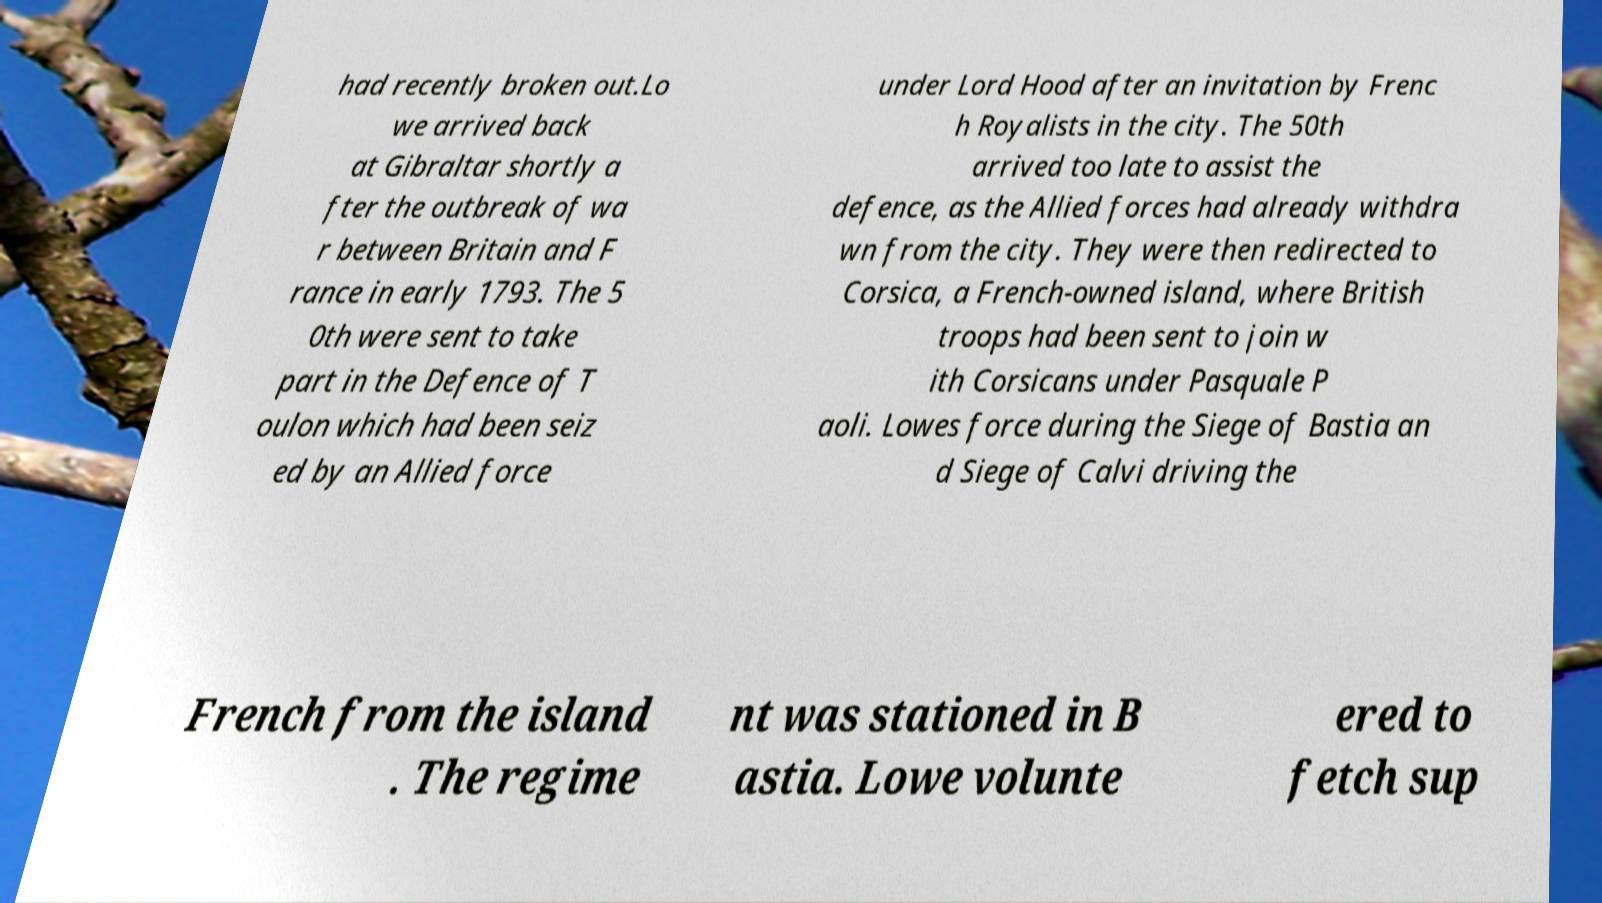Can you read and provide the text displayed in the image?This photo seems to have some interesting text. Can you extract and type it out for me? had recently broken out.Lo we arrived back at Gibraltar shortly a fter the outbreak of wa r between Britain and F rance in early 1793. The 5 0th were sent to take part in the Defence of T oulon which had been seiz ed by an Allied force under Lord Hood after an invitation by Frenc h Royalists in the city. The 50th arrived too late to assist the defence, as the Allied forces had already withdra wn from the city. They were then redirected to Corsica, a French-owned island, where British troops had been sent to join w ith Corsicans under Pasquale P aoli. Lowes force during the Siege of Bastia an d Siege of Calvi driving the French from the island . The regime nt was stationed in B astia. Lowe volunte ered to fetch sup 